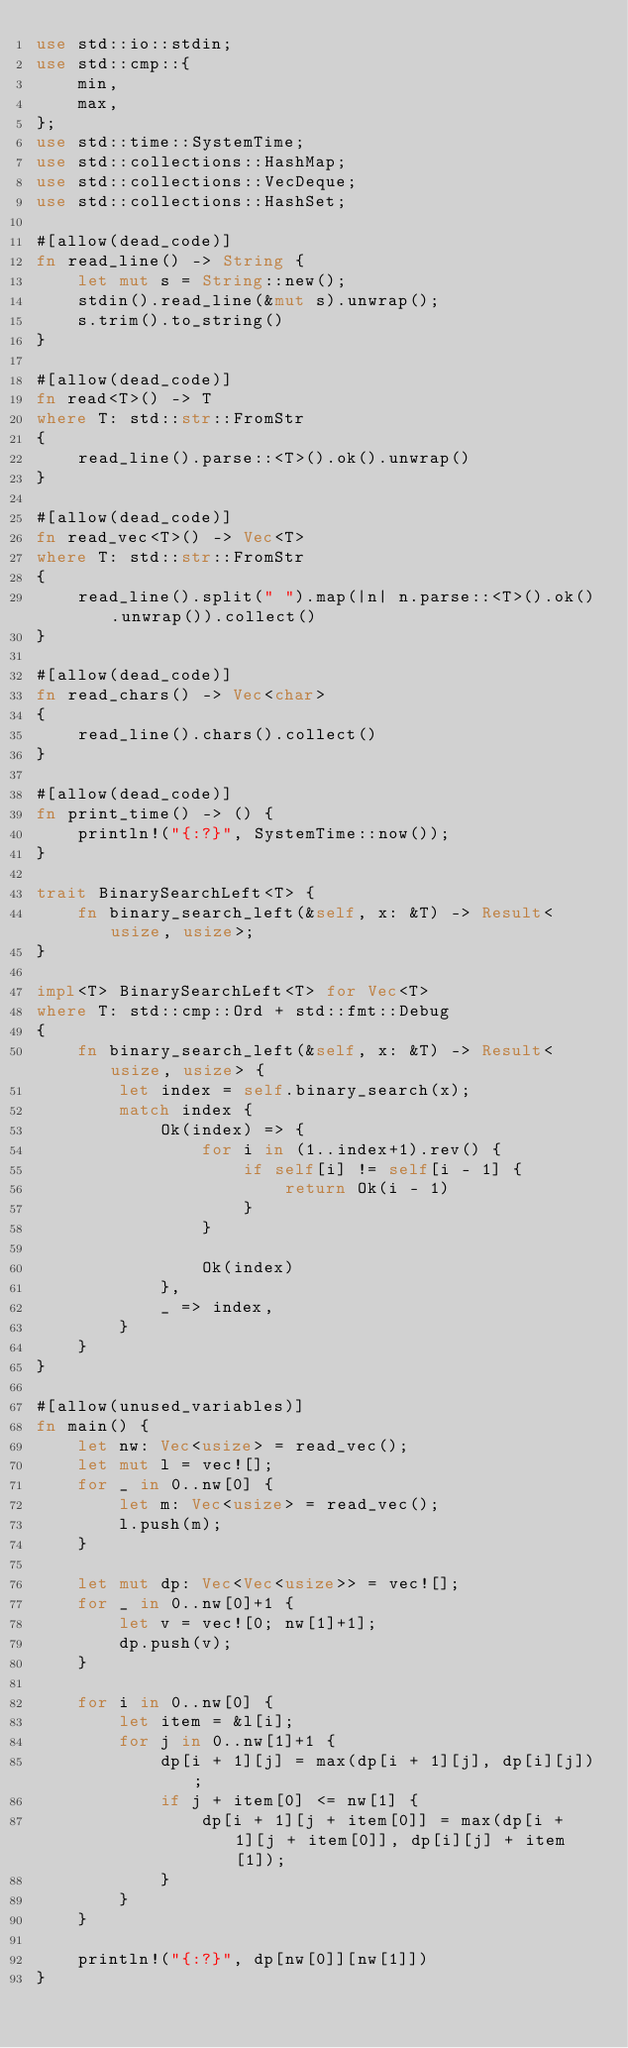Convert code to text. <code><loc_0><loc_0><loc_500><loc_500><_Rust_>use std::io::stdin;
use std::cmp::{
    min,
    max,
};
use std::time::SystemTime;
use std::collections::HashMap;
use std::collections::VecDeque;
use std::collections::HashSet;

#[allow(dead_code)]
fn read_line() -> String {
    let mut s = String::new();
    stdin().read_line(&mut s).unwrap();
    s.trim().to_string()
}

#[allow(dead_code)]
fn read<T>() -> T
where T: std::str::FromStr
{
    read_line().parse::<T>().ok().unwrap()
}

#[allow(dead_code)]
fn read_vec<T>() -> Vec<T>
where T: std::str::FromStr
{
    read_line().split(" ").map(|n| n.parse::<T>().ok().unwrap()).collect()
}

#[allow(dead_code)]
fn read_chars() -> Vec<char>
{
    read_line().chars().collect()
}

#[allow(dead_code)]
fn print_time() -> () {
    println!("{:?}", SystemTime::now());
}

trait BinarySearchLeft<T> {
    fn binary_search_left(&self, x: &T) -> Result<usize, usize>;
}

impl<T> BinarySearchLeft<T> for Vec<T>
where T: std::cmp::Ord + std::fmt::Debug
{
    fn binary_search_left(&self, x: &T) -> Result<usize, usize> {
        let index = self.binary_search(x);
        match index {
            Ok(index) => {
                for i in (1..index+1).rev() {
                    if self[i] != self[i - 1] {
                        return Ok(i - 1)
                    }
                }
                
                Ok(index)
            },
            _ => index,
        }
    }
}

#[allow(unused_variables)]
fn main() {
    let nw: Vec<usize> = read_vec();
    let mut l = vec![];
    for _ in 0..nw[0] {
        let m: Vec<usize> = read_vec();
        l.push(m);
    }

    let mut dp: Vec<Vec<usize>> = vec![];
    for _ in 0..nw[0]+1 {
        let v = vec![0; nw[1]+1];
        dp.push(v);
    }

    for i in 0..nw[0] {
        let item = &l[i];
        for j in 0..nw[1]+1 {
            dp[i + 1][j] = max(dp[i + 1][j], dp[i][j]);
            if j + item[0] <= nw[1] {
                dp[i + 1][j + item[0]] = max(dp[i + 1][j + item[0]], dp[i][j] + item[1]);
            }
        }
    }

    println!("{:?}", dp[nw[0]][nw[1]])
}
</code> 